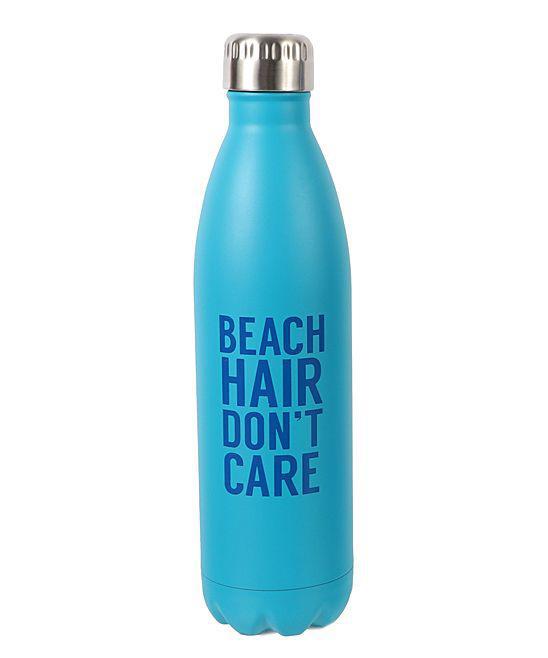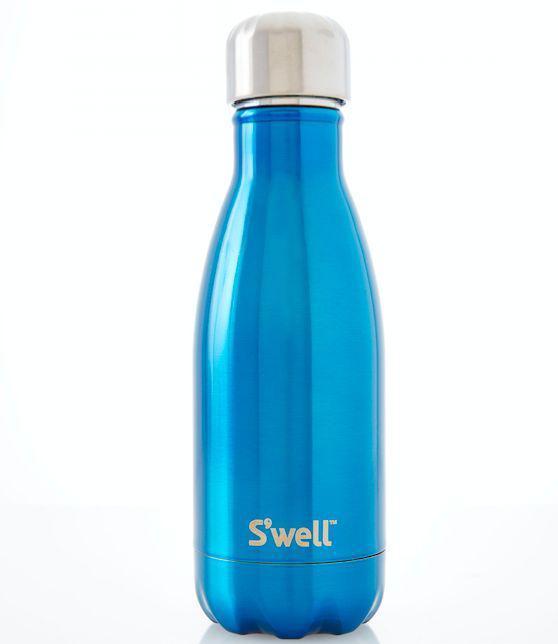The first image is the image on the left, the second image is the image on the right. Examine the images to the left and right. Is the description "The image on the left contains a dark blue bottle." accurate? Answer yes or no. No. 